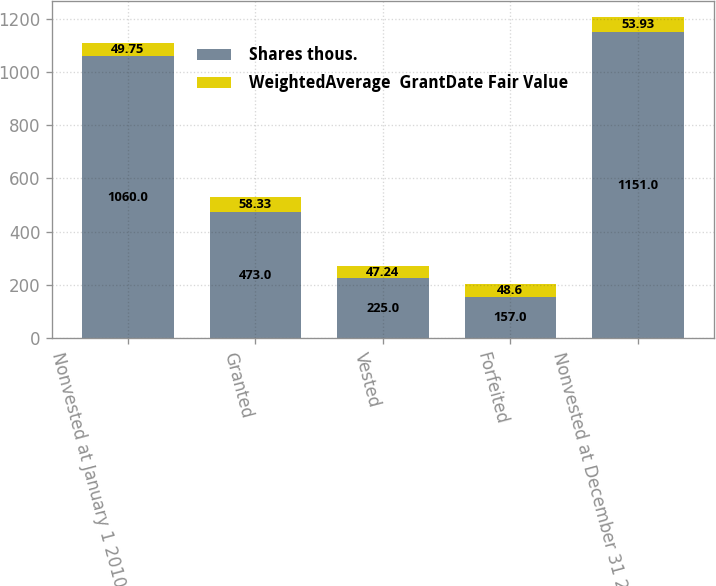Convert chart to OTSL. <chart><loc_0><loc_0><loc_500><loc_500><stacked_bar_chart><ecel><fcel>Nonvested at January 1 2010<fcel>Granted<fcel>Vested<fcel>Forfeited<fcel>Nonvested at December 31 2010<nl><fcel>Shares thous.<fcel>1060<fcel>473<fcel>225<fcel>157<fcel>1151<nl><fcel>WeightedAverage  GrantDate Fair Value<fcel>49.75<fcel>58.33<fcel>47.24<fcel>48.6<fcel>53.93<nl></chart> 